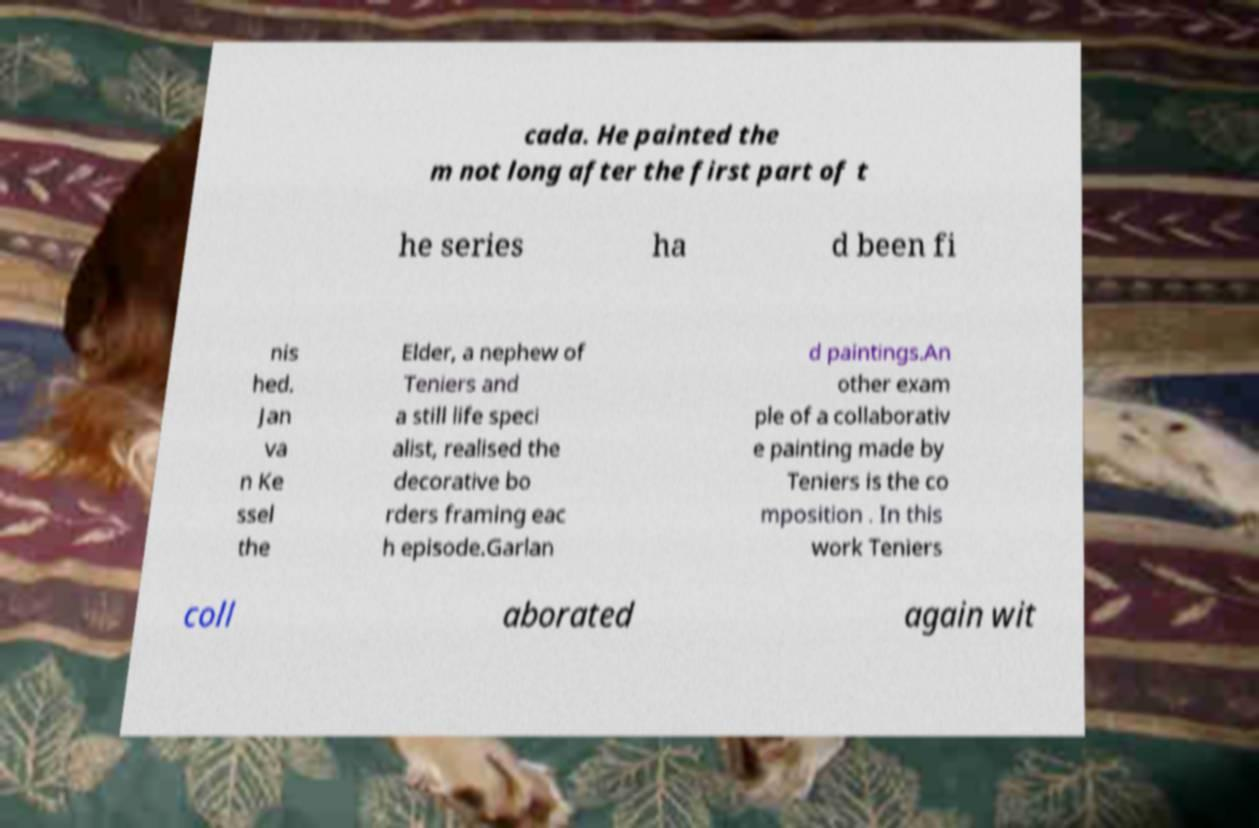Can you accurately transcribe the text from the provided image for me? cada. He painted the m not long after the first part of t he series ha d been fi nis hed. Jan va n Ke ssel the Elder, a nephew of Teniers and a still life speci alist, realised the decorative bo rders framing eac h episode.Garlan d paintings.An other exam ple of a collaborativ e painting made by Teniers is the co mposition . In this work Teniers coll aborated again wit 